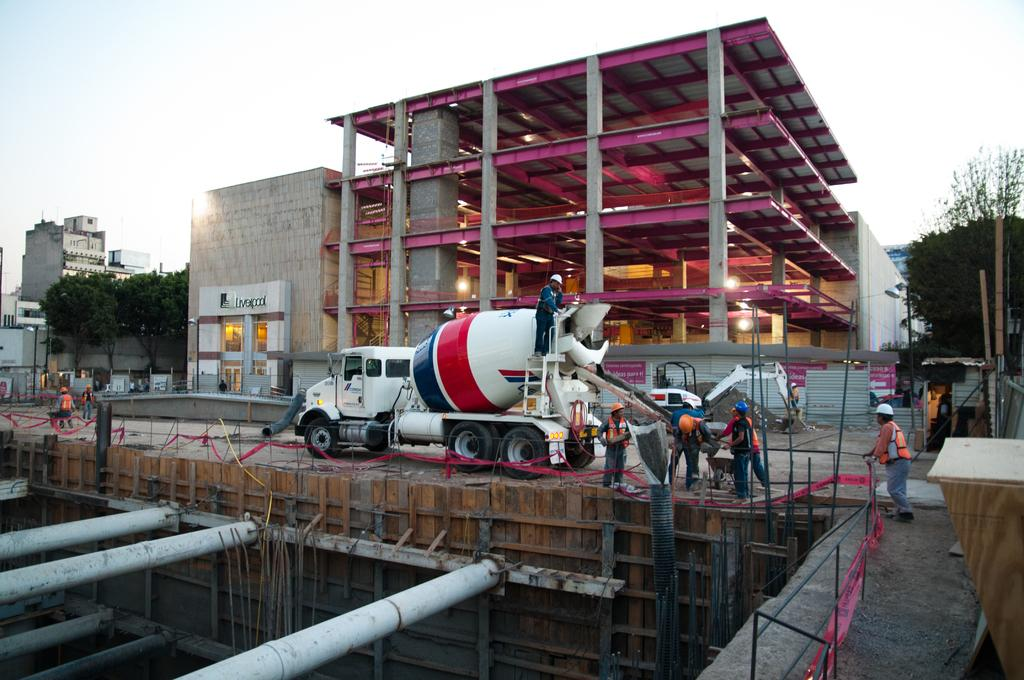What types of objects can be seen in the image? There are people, vehicles, wooden objects, poles, pipes, and rods in the image. What structures are visible in the background of the image? The background of the image includes buildings, walls, trees, pillars, lights, and poles. What is visible in the sky in the image? The sky is visible in the background of the image. What type of hospital can be seen in the image? There is no hospital present in the image. What kind of paper is being used by the people in the image? There is no paper visible in the image. 